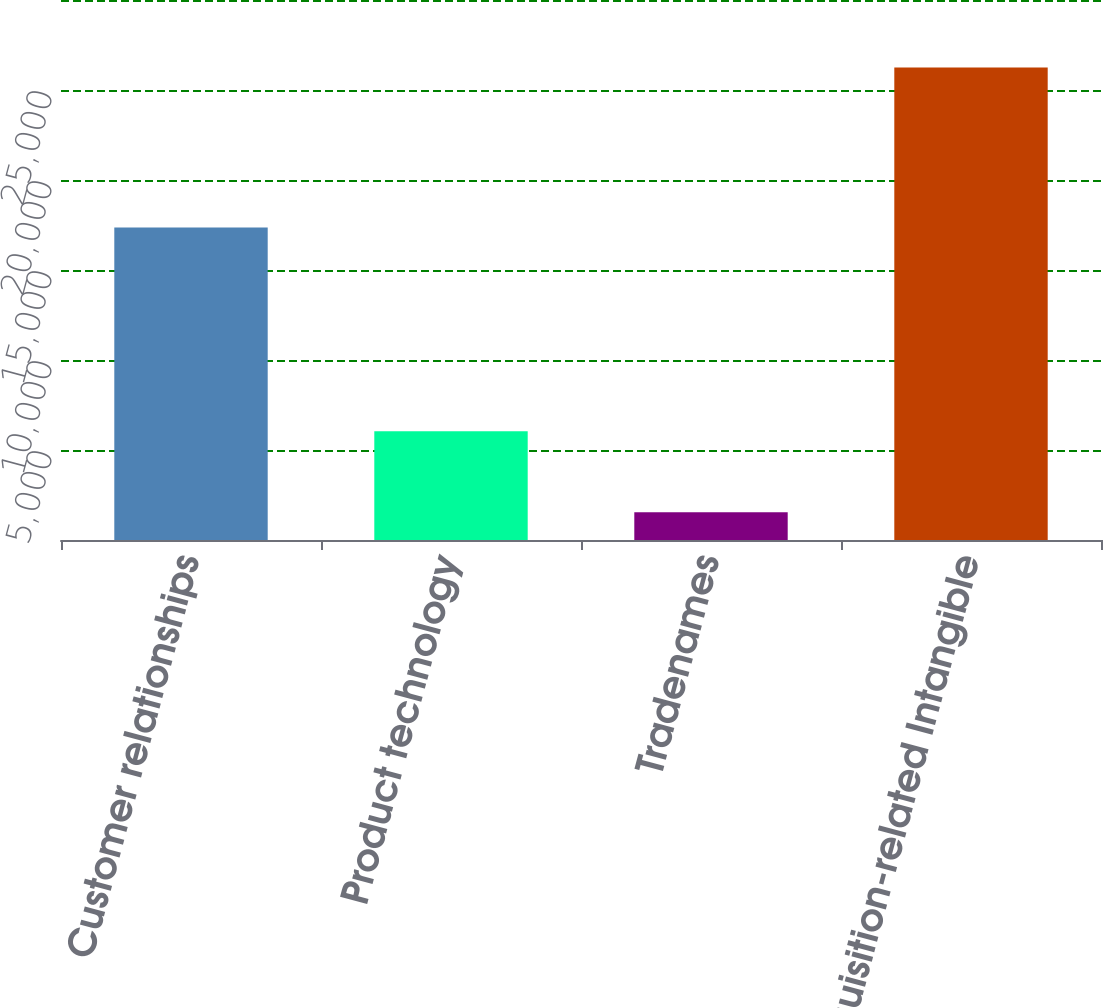<chart> <loc_0><loc_0><loc_500><loc_500><bar_chart><fcel>Customer relationships<fcel>Product technology<fcel>Tradenames<fcel>Acquisition-related Intangible<nl><fcel>17356<fcel>6046<fcel>1538<fcel>26248<nl></chart> 